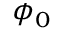Convert formula to latex. <formula><loc_0><loc_0><loc_500><loc_500>\phi _ { 0 }</formula> 